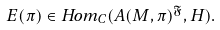Convert formula to latex. <formula><loc_0><loc_0><loc_500><loc_500>E ( \pi ) \in H o m _ { C } ( A ( M , \pi ) ^ { \mathfrak { F } } , H ) .</formula> 